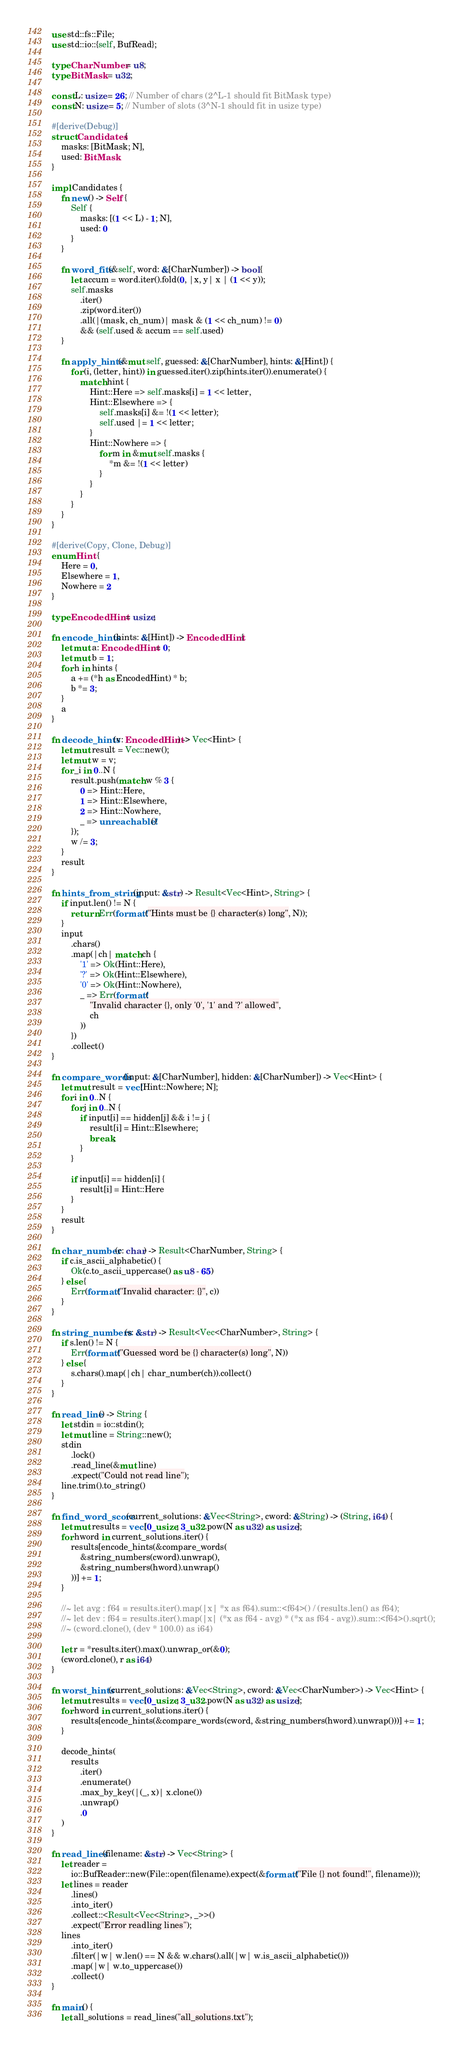Convert code to text. <code><loc_0><loc_0><loc_500><loc_500><_Rust_>use std::fs::File;
use std::io::{self, BufRead};

type CharNumber = u8;
type BitMask = u32;

const L: usize = 26; // Number of chars (2^L-1 should fit BitMask type)
const N: usize = 5; // Number of slots (3^N-1 should fit in usize type)

#[derive(Debug)]
struct Candidates {
    masks: [BitMask; N],
    used: BitMask
}

impl Candidates {
    fn new() -> Self {
        Self {
            masks: [(1 << L) - 1; N],
            used: 0
        }
    }

    fn word_fits(&self, word: &[CharNumber]) -> bool {
        let accum = word.iter().fold(0, |x, y| x | (1 << y));
        self.masks
            .iter()
            .zip(word.iter())
            .all(|(mask, ch_num)| mask & (1 << ch_num) != 0)
            && (self.used & accum == self.used)
    }

    fn apply_hints(&mut self, guessed: &[CharNumber], hints: &[Hint]) {
        for (i, (letter, hint)) in guessed.iter().zip(hints.iter()).enumerate() {
            match hint {
                Hint::Here => self.masks[i] = 1 << letter,
                Hint::Elsewhere => {
                    self.masks[i] &= !(1 << letter);
                    self.used |= 1 << letter;
                }
                Hint::Nowhere => {
                    for m in &mut self.masks {
                        *m &= !(1 << letter)
                    }
                }
            }
        }
    }
}

#[derive(Copy, Clone, Debug)]
enum Hint {
    Here = 0,
    Elsewhere = 1,
    Nowhere = 2
}

type EncodedHint = usize;

fn encode_hints(hints: &[Hint]) -> EncodedHint {
    let mut a: EncodedHint = 0;
    let mut b = 1;
    for h in hints {
        a += (*h as EncodedHint) * b;
        b *= 3;
    }
    a
}

fn decode_hints(v: EncodedHint) -> Vec<Hint> {
    let mut result = Vec::new();
    let mut w = v;
    for _i in 0..N {
        result.push(match w % 3 {
            0 => Hint::Here,
            1 => Hint::Elsewhere,
            2 => Hint::Nowhere,
            _ => unreachable!()
        });
        w /= 3;
    }
    result
}

fn hints_from_string(input: &str) -> Result<Vec<Hint>, String> {
    if input.len() != N {
        return Err(format!("Hints must be {} character(s) long", N));
    }
    input
        .chars()
        .map(|ch| match ch {
            '1' => Ok(Hint::Here),
            '?' => Ok(Hint::Elsewhere),
            '0' => Ok(Hint::Nowhere),
            _ => Err(format!(
                "Invalid character {}, only '0', '1' and '?' allowed",
                ch
            ))
        })
        .collect()
}

fn compare_words(input: &[CharNumber], hidden: &[CharNumber]) -> Vec<Hint> {
    let mut result = vec![Hint::Nowhere; N];
    for i in 0..N {
        for j in 0..N {
            if input[i] == hidden[j] && i != j {
                result[i] = Hint::Elsewhere;
                break;
            }
        }

        if input[i] == hidden[i] {
            result[i] = Hint::Here
        }
    }
    result
}

fn char_number(c: char) -> Result<CharNumber, String> {
    if c.is_ascii_alphabetic() {
        Ok(c.to_ascii_uppercase() as u8 - 65)
    } else {
        Err(format!("Invalid character: {}", c))
    }
}

fn string_numbers(s: &str) -> Result<Vec<CharNumber>, String> {
    if s.len() != N {
        Err(format!("Guessed word be {} character(s) long", N))
    } else {
        s.chars().map(|ch| char_number(ch)).collect()
    }
}

fn read_line() -> String {
    let stdin = io::stdin();
    let mut line = String::new();
    stdin
        .lock()
        .read_line(&mut line)
        .expect("Could not read line");
    line.trim().to_string()
}

fn find_word_score(current_solutions: &Vec<String>, cword: &String) -> (String, i64) {
    let mut results = vec![0_usize; 3_u32.pow(N as u32) as usize];
    for hword in current_solutions.iter() {
        results[encode_hints(&compare_words(
            &string_numbers(cword).unwrap(),
            &string_numbers(hword).unwrap()
        ))] += 1;
    }

    //~ let avg : f64 = results.iter().map(|x| *x as f64).sum::<f64>() / (results.len() as f64);
    //~ let dev : f64 = results.iter().map(|x| (*x as f64 - avg) * (*x as f64 - avg)).sum::<f64>().sqrt();
    //~ (cword.clone(), (dev * 100.0) as i64)

    let r = *results.iter().max().unwrap_or(&0);
    (cword.clone(), r as i64)
}

fn worst_hints(current_solutions: &Vec<String>, cword: &Vec<CharNumber>) -> Vec<Hint> {
    let mut results = vec![0_usize; 3_u32.pow(N as u32) as usize];
    for hword in current_solutions.iter() {
        results[encode_hints(&compare_words(cword, &string_numbers(hword).unwrap()))] += 1;
    }

    decode_hints(
        results
            .iter()
            .enumerate()
            .max_by_key(|(_, x)| x.clone())
            .unwrap()
            .0
    )
}

fn read_lines(filename: &str) -> Vec<String> {
    let reader =
        io::BufReader::new(File::open(filename).expect(&format!("File {} not found!", filename)));
    let lines = reader
        .lines()
        .into_iter()
        .collect::<Result<Vec<String>, _>>()
        .expect("Error readling lines");
    lines
        .into_iter()
        .filter(|w| w.len() == N && w.chars().all(|w| w.is_ascii_alphabetic()))
        .map(|w| w.to_uppercase())
        .collect()
}

fn main() {
    let all_solutions = read_lines("all_solutions.txt");</code> 